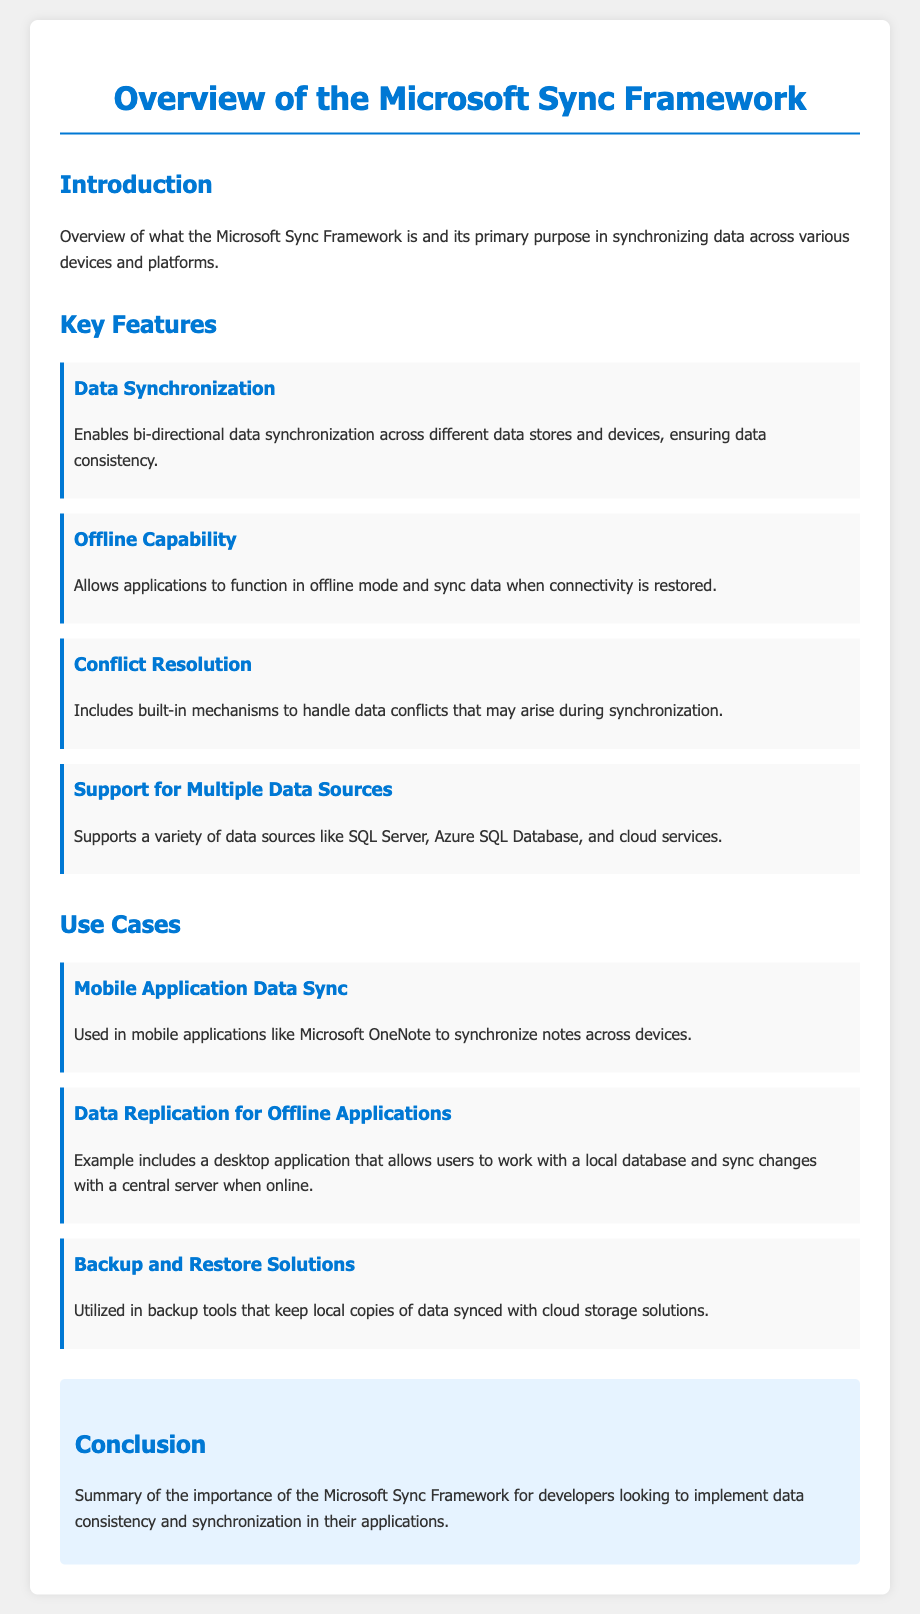What is the primary purpose of the Microsoft Sync Framework? The primary purpose is to synchronize data across various devices and platforms.
Answer: synchronizing data How many key features are listed in the document? The document lists four key features under the "Key Features" section.
Answer: four What is one of the built-in mechanisms mentioned for handling data conflicts? The document states that it includes built-in mechanisms to handle data conflicts during synchronization.
Answer: conflict resolution Which mobile application is mentioned as an example of data synchronization? The document mentions Microsoft OneNote as a mobile application that synchronizes notes across devices.
Answer: Microsoft OneNote What capability does the Microsoft Sync Framework provide for applications when offline? The document states that it allows applications to function in offline mode.
Answer: offline capability What is one use case of the Microsoft Sync Framework mentioned in the document? The document lists data replication for offline applications as one use case example.
Answer: data replication for offline applications What kind of data sources does the Microsoft Sync Framework support? The document states that it supports a variety of data sources like SQL Server and Azure SQL Database.
Answer: multiple data sources What is the conclusion about the importance of the Microsoft Sync Framework? The conclusion summarizes the importance for developers looking to implement data consistency and synchronization.
Answer: data consistency and synchronization 